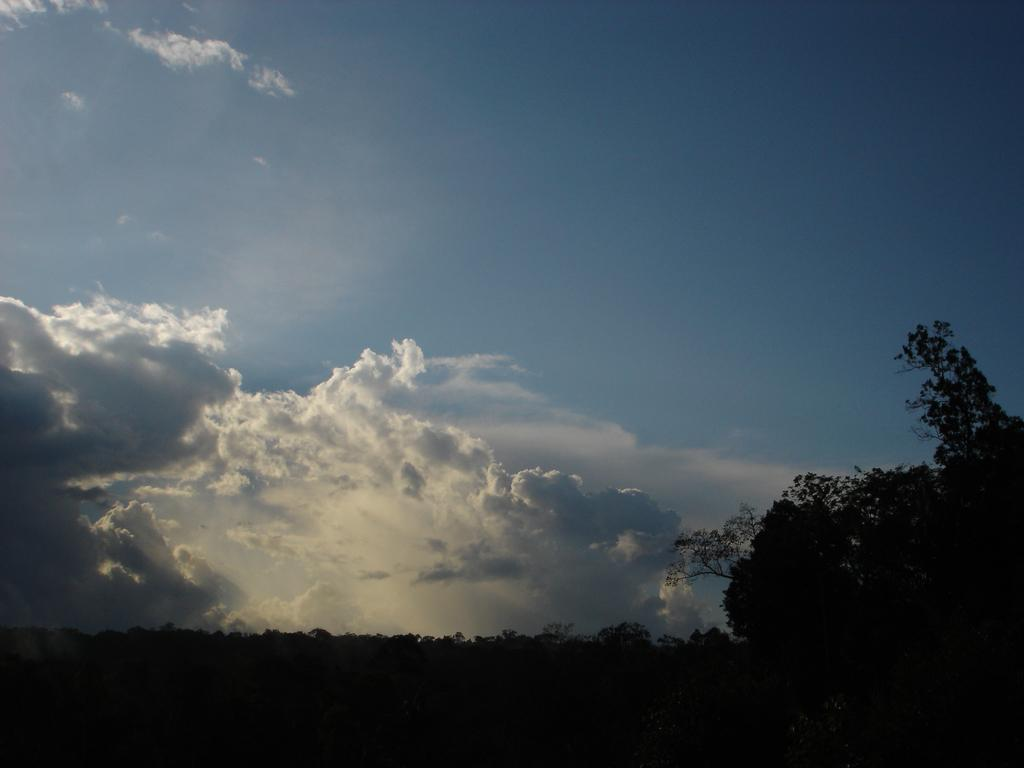What type of vegetation can be seen in the image? There are trees in the image. What part of the natural environment is visible in the image? The sky is visible in the image. What is the condition of the sky in the image? The sky appears to be cloudy in the image. Where is the shelf located in the image? There is no shelf present in the image. Can you see the mom in the image? There is no person, including a mom, present in the image. What type of work environment is depicted in the image? The image does not depict an office or any work environment; it features trees and a cloudy sky. 